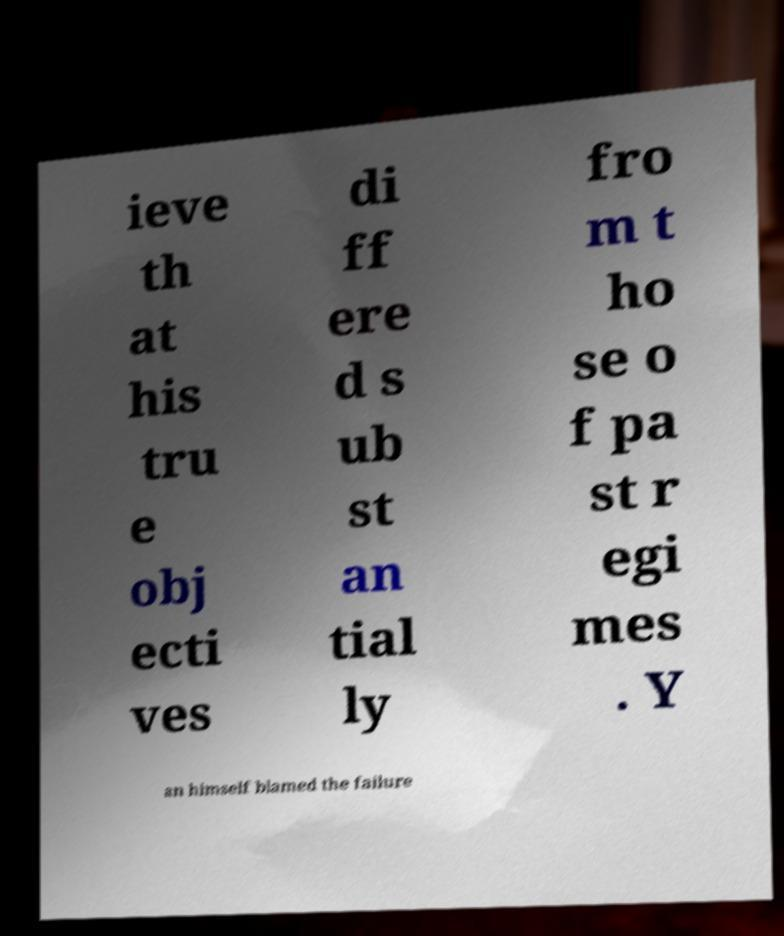I need the written content from this picture converted into text. Can you do that? ieve th at his tru e obj ecti ves di ff ere d s ub st an tial ly fro m t ho se o f pa st r egi mes . Y an himself blamed the failure 